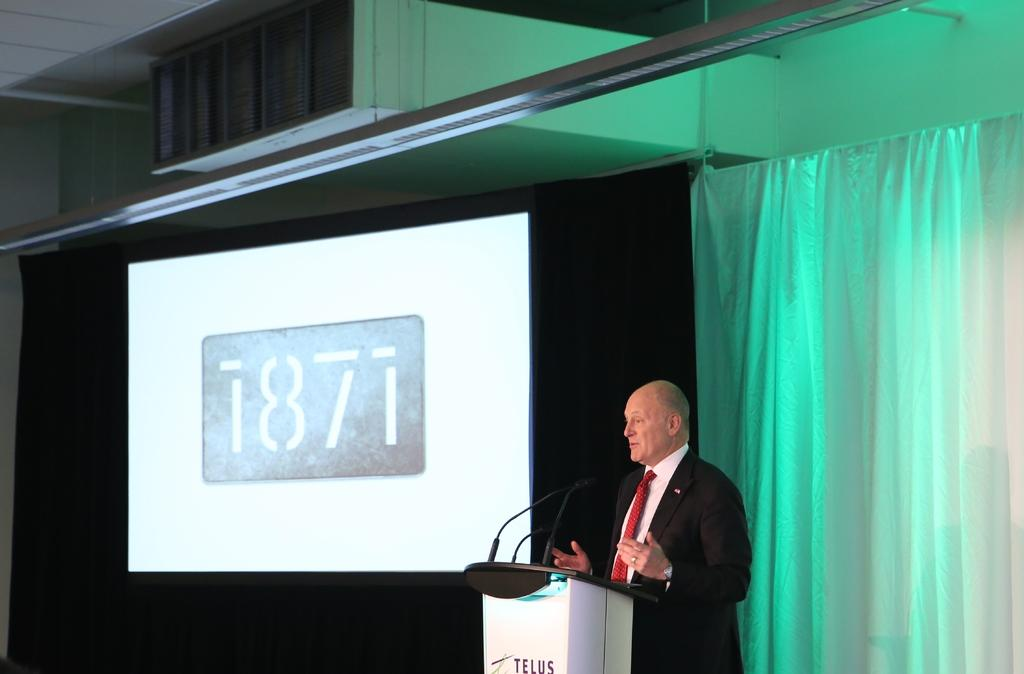What is the man in the image doing? The man is standing at the podium. What is on the podium with the man? Microphones are present on the podium. What can be seen in the background of the image? There is a screen, a curtain, a wall, and other objects visible in the background. What type of plant is the man discussing with his partner in the image? There is no plant or partner present in the image; the man is standing at the podium with microphones. 